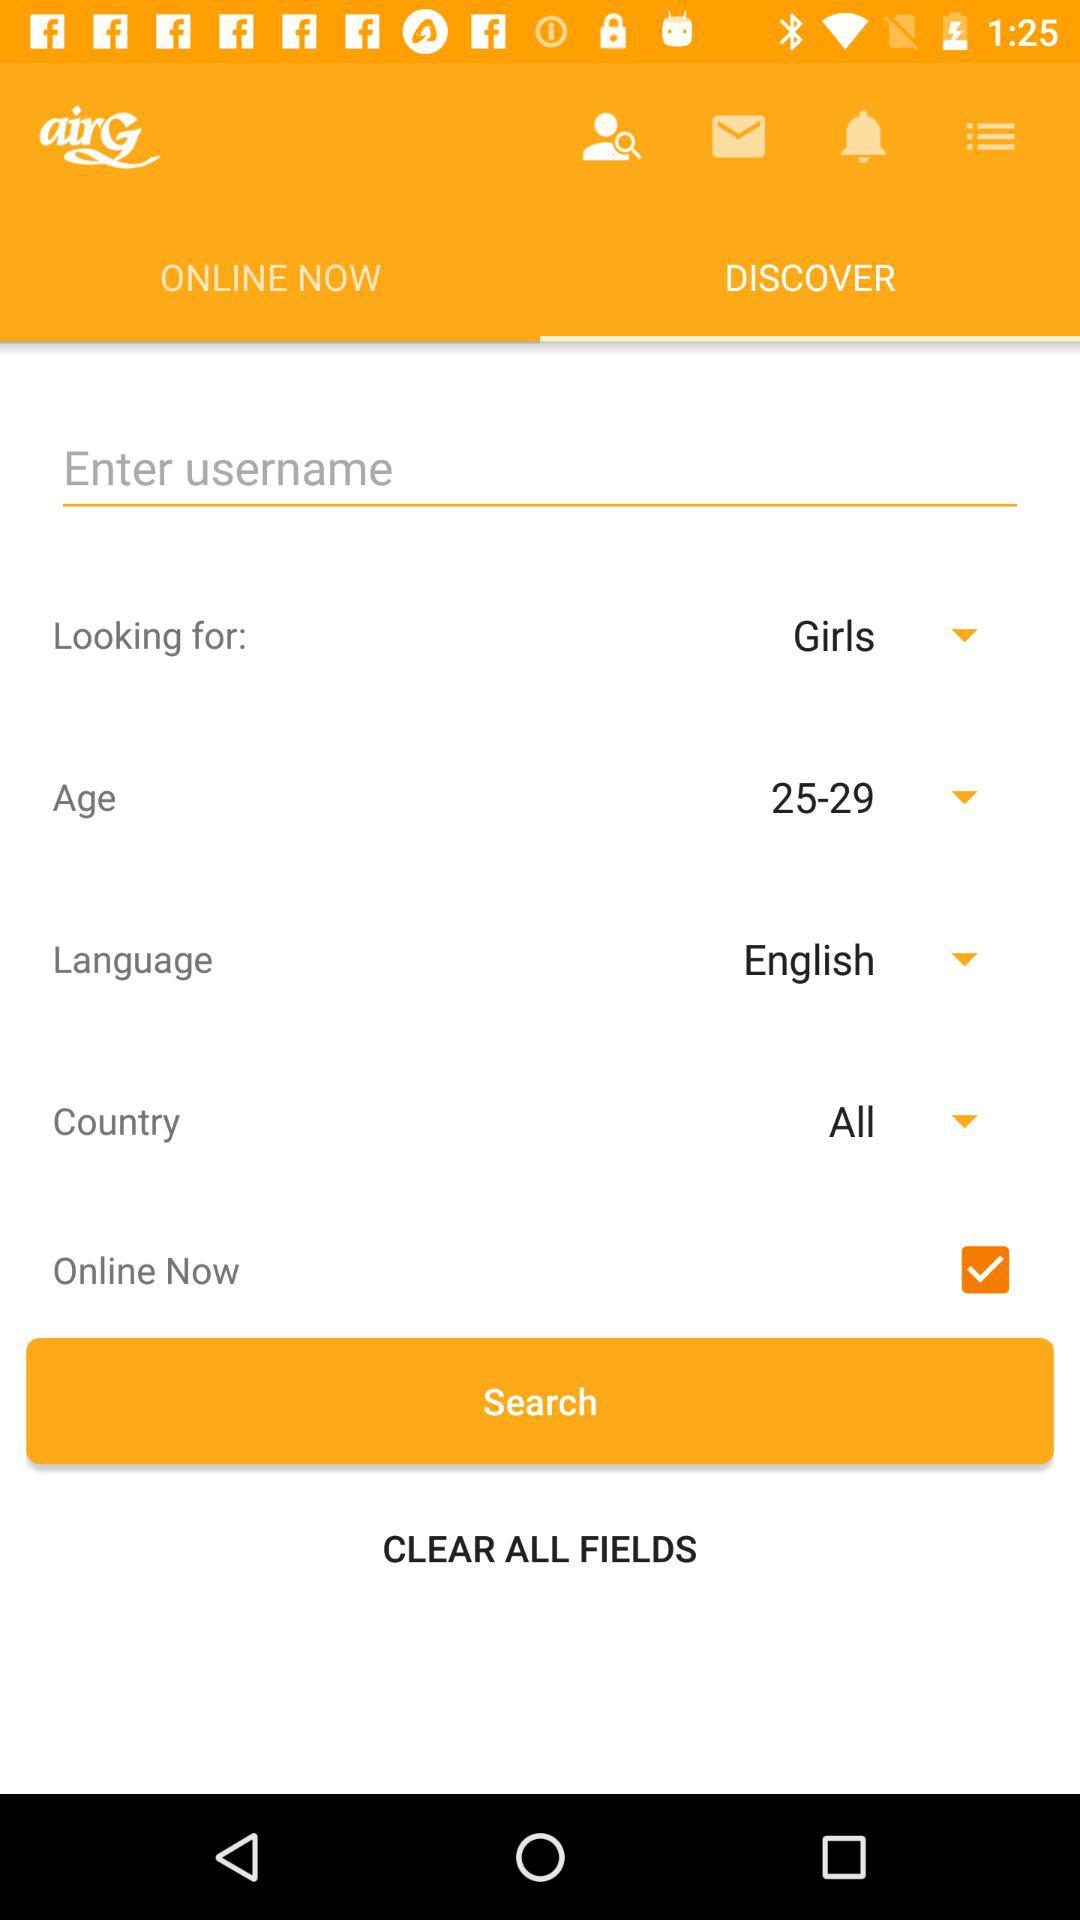What is the age? The age is 25–29. 